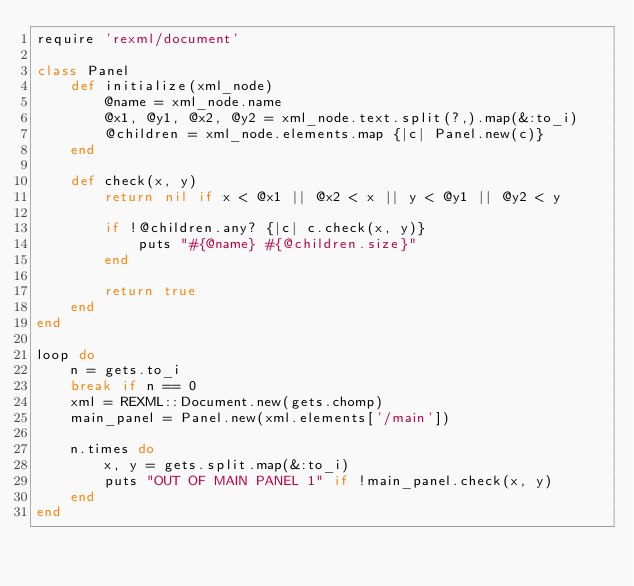Convert code to text. <code><loc_0><loc_0><loc_500><loc_500><_Ruby_>require 'rexml/document'

class Panel
    def initialize(xml_node)
        @name = xml_node.name
        @x1, @y1, @x2, @y2 = xml_node.text.split(?,).map(&:to_i)
        @children = xml_node.elements.map {|c| Panel.new(c)}
    end

    def check(x, y)
        return nil if x < @x1 || @x2 < x || y < @y1 || @y2 < y

        if !@children.any? {|c| c.check(x, y)}
            puts "#{@name} #{@children.size}"
        end

        return true
    end
end

loop do
    n = gets.to_i
    break if n == 0
    xml = REXML::Document.new(gets.chomp)
    main_panel = Panel.new(xml.elements['/main'])

    n.times do
        x, y = gets.split.map(&:to_i)
        puts "OUT OF MAIN PANEL 1" if !main_panel.check(x, y)
    end
end</code> 